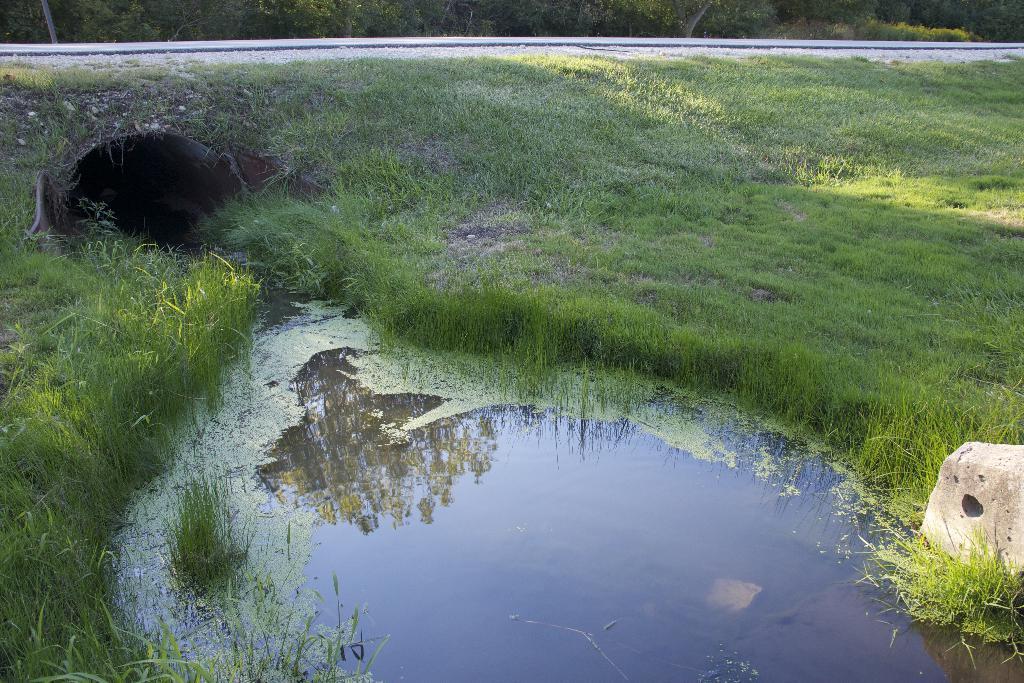In one or two sentences, can you explain what this image depicts? In the center of the image there is a hole, one white color solid structure, grass, plants, water and a few other objects. 